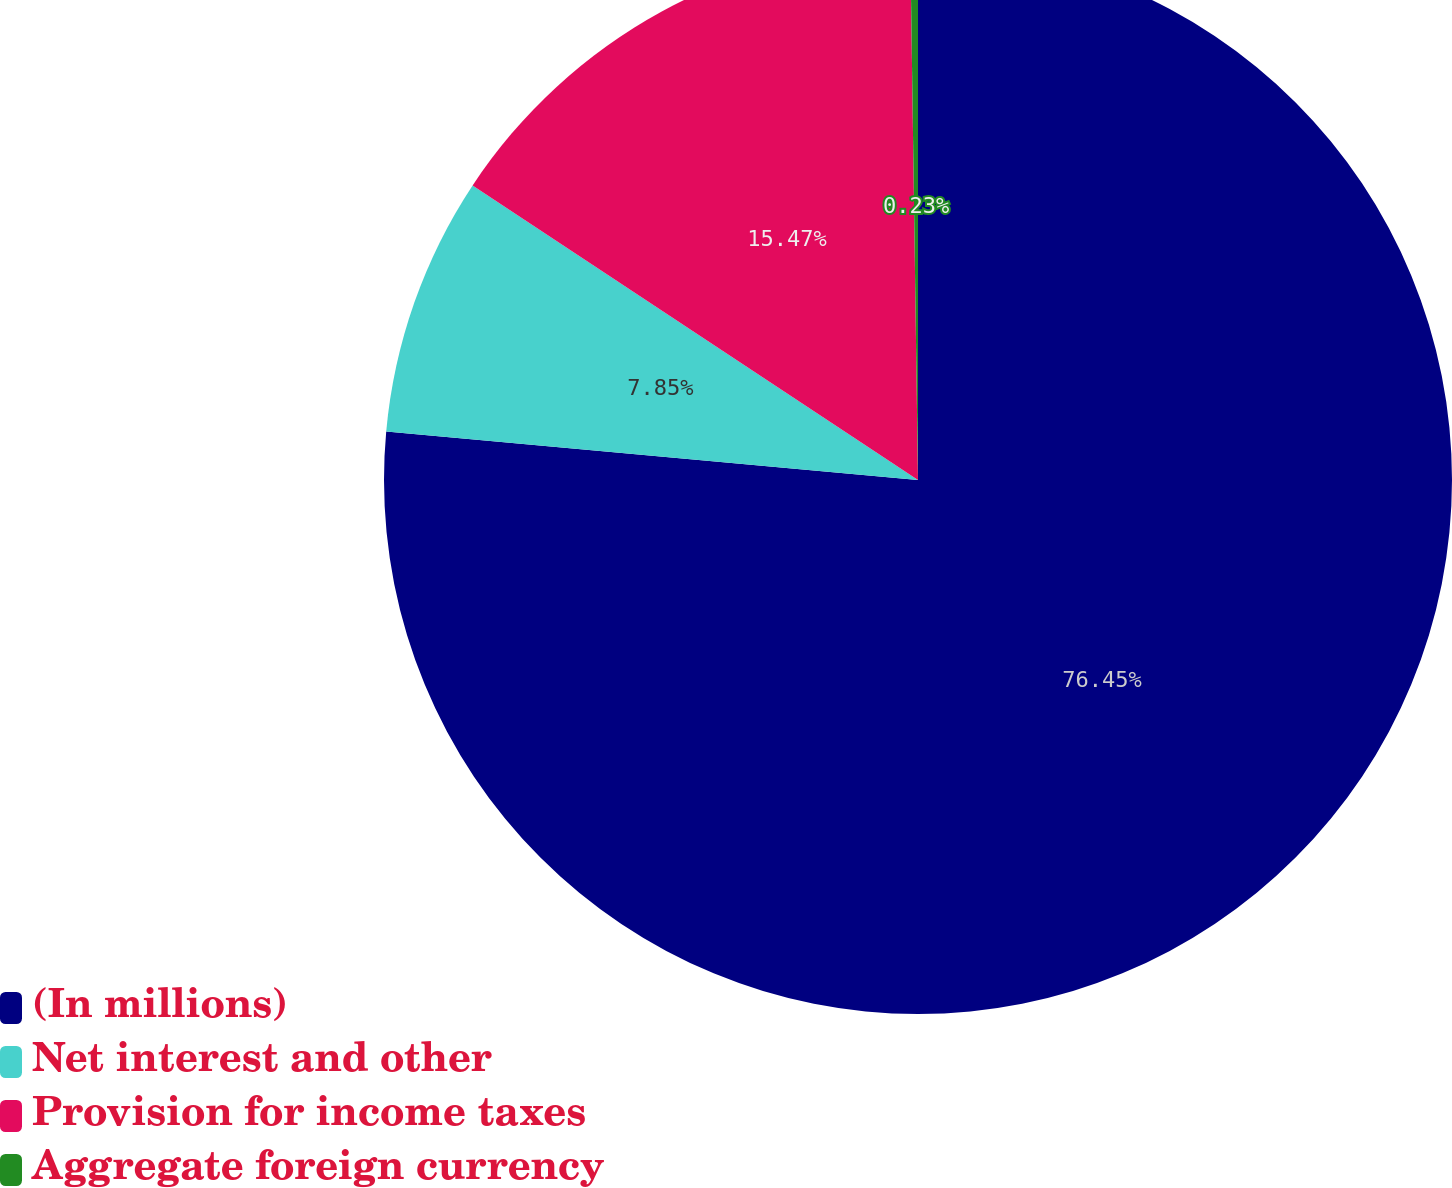<chart> <loc_0><loc_0><loc_500><loc_500><pie_chart><fcel>(In millions)<fcel>Net interest and other<fcel>Provision for income taxes<fcel>Aggregate foreign currency<nl><fcel>76.45%<fcel>7.85%<fcel>15.47%<fcel>0.23%<nl></chart> 